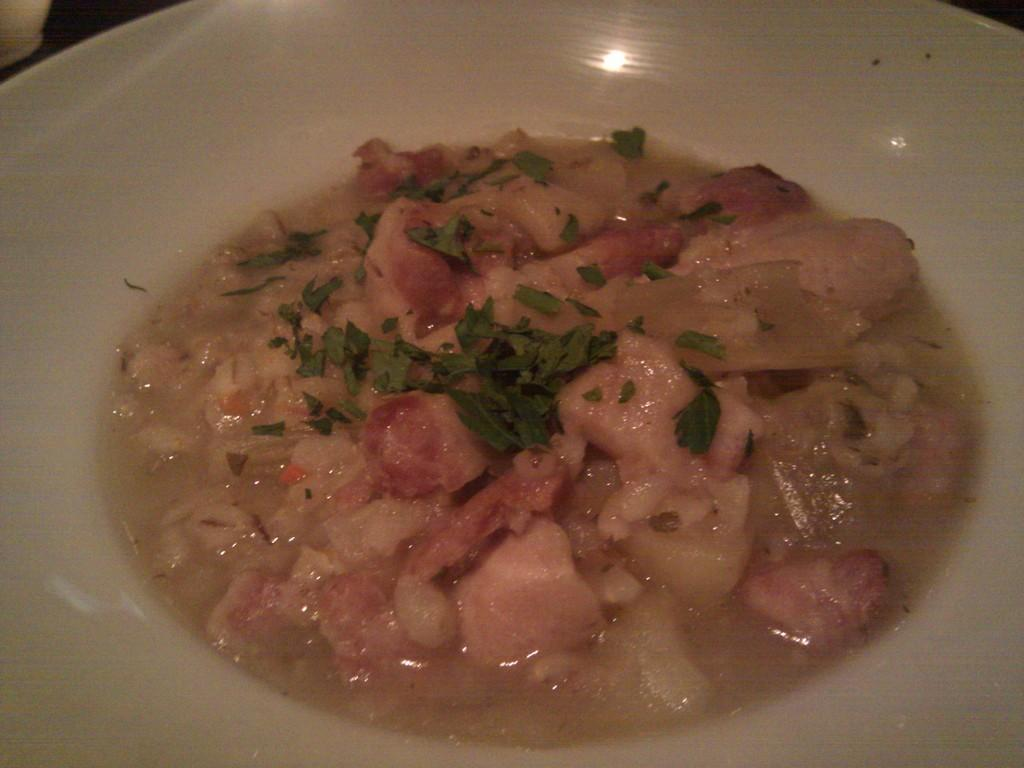What is placed on the plate in the image? There is food placed on a plate in the image. What type of quilt is being used to drain the food in the image? There is no quilt or draining activity present in the image; it simply shows food placed on a plate. 